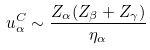Convert formula to latex. <formula><loc_0><loc_0><loc_500><loc_500>u _ { \alpha } ^ { C } \sim \frac { Z _ { \alpha } ( Z _ { \beta } + Z _ { \gamma } ) } { \eta _ { \alpha } }</formula> 